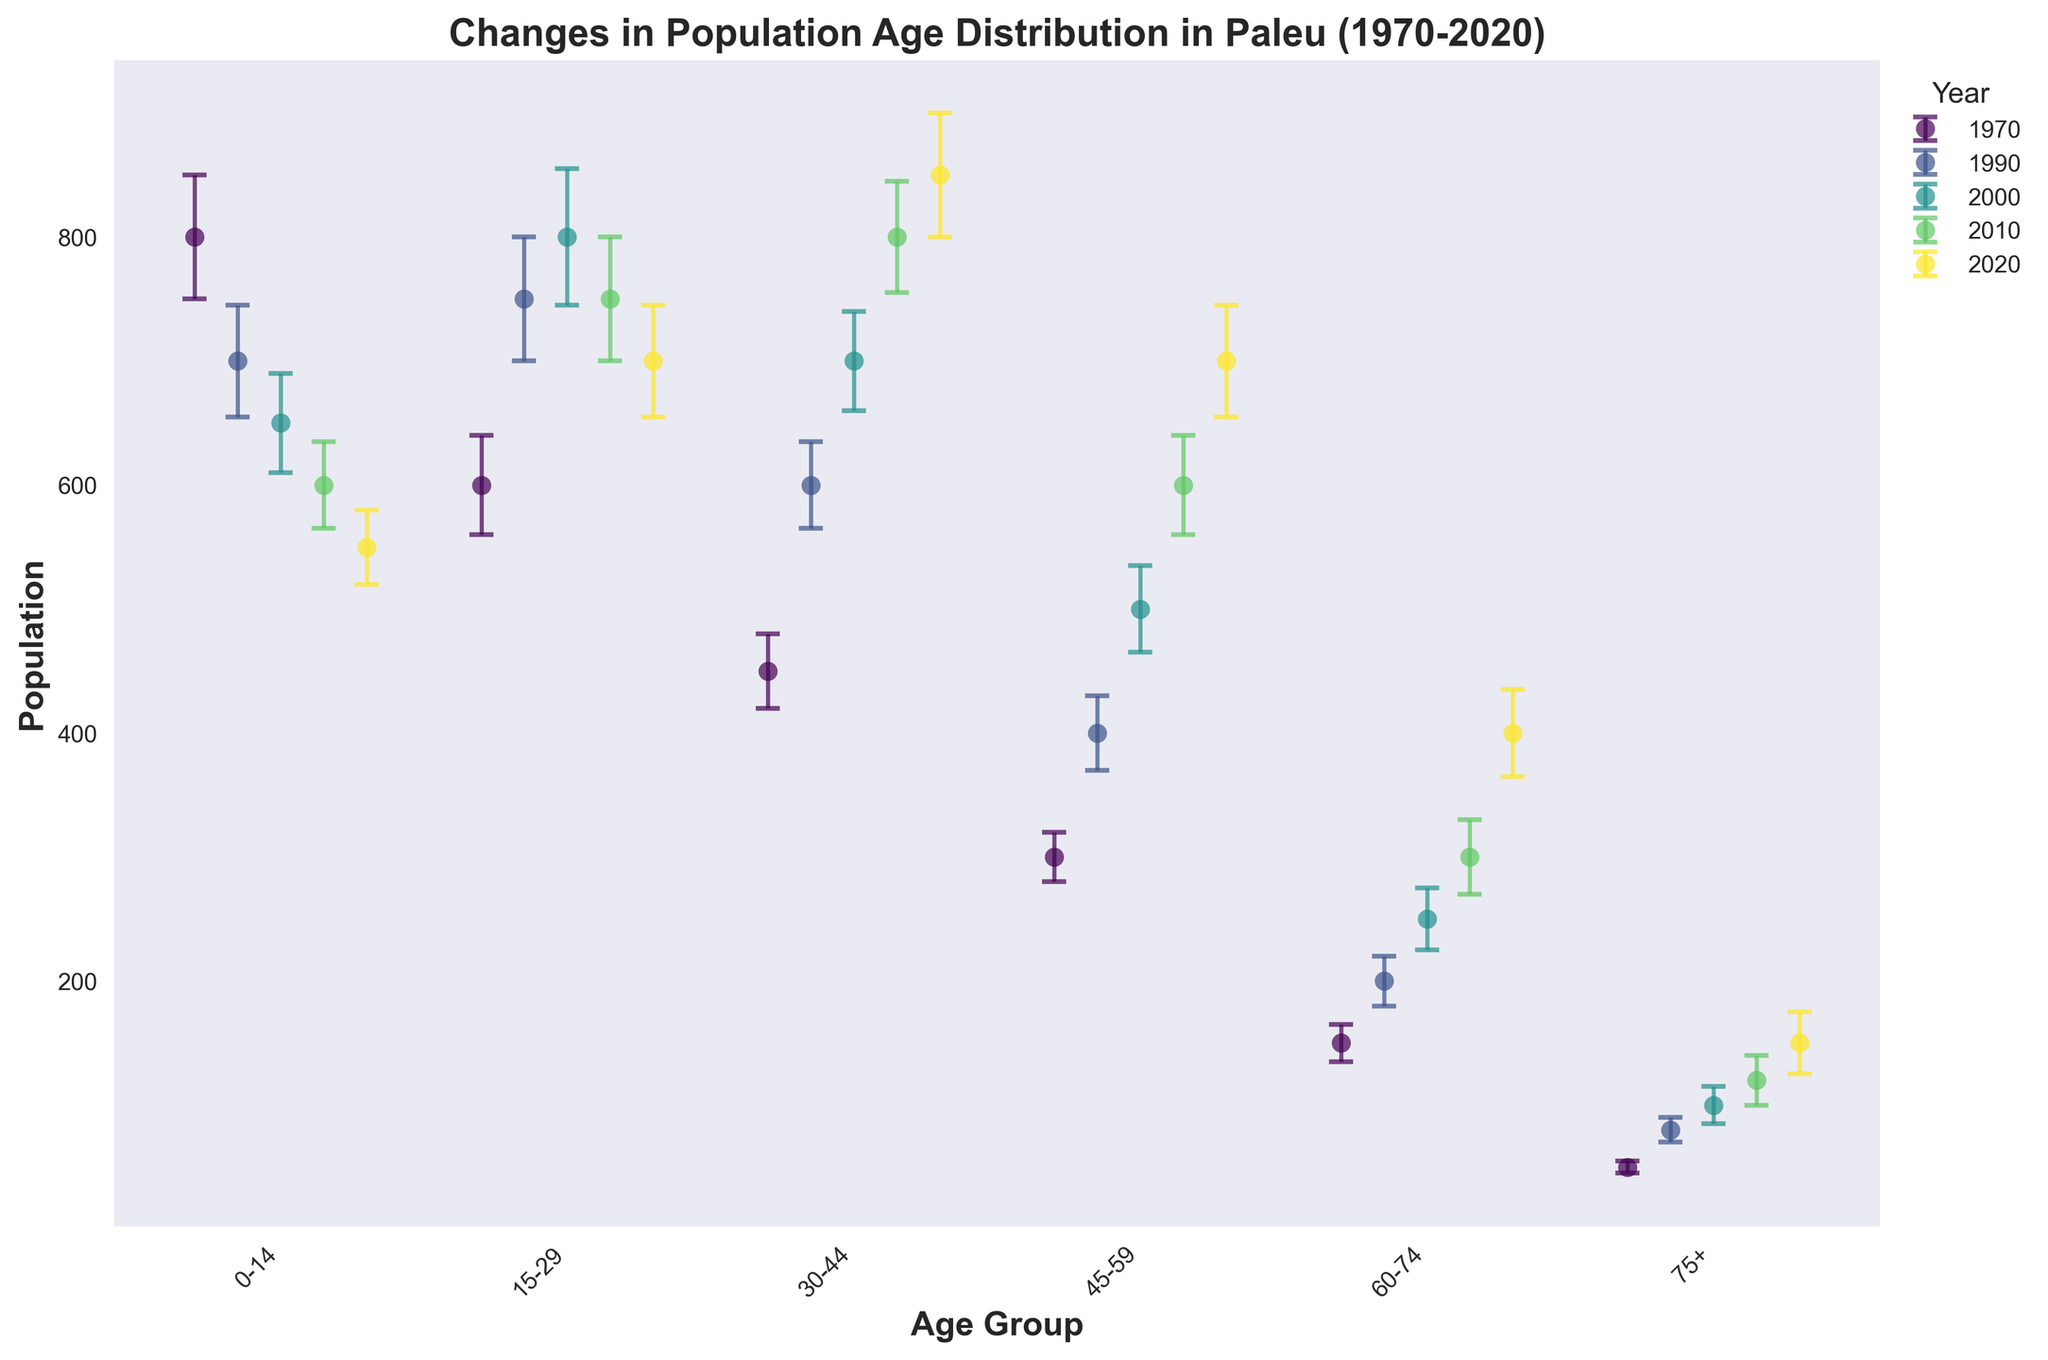What's the title of the figure? The title of the figure is typically displayed at the top of the chart. In this case, it should be obvious to spot when looking at the overall plot.
Answer: Changes in Population Age Distribution in Paleu (1970-2020) Which age group had the highest population in 2020? To determine the age group with the highest population in 2020, locate the 2020 data points and identify which age group has the highest value.
Answer: 30-44 How did the population of the age group 0-14 change from 1970 to 2020? Identify the population values for the age group 0-14 in both 1970 and 2020. Compare the two values to see the change.
Answer: Decreased What is the average population of the 60-74 age group across all years? Calculate the population for the 60-74 age group in each year (1970, 1990, 2000, 2010, 2020). Add these values and divide by the number of years. (150 + 200 + 250 + 300 + 400) / 5 = 260
Answer: 260 In which year did the age group 75+ have the lowest population? Check the population values for the age group 75+ across all years and identify the year with the lowest value.
Answer: 1970 For the year 2000, how does the population of the 45-59 age group compare to the 15-29 age group? Find the population values for the 45-59 and 15-29 age groups in 2000. Compare these values to see which is higher.
Answer: 15-29 is higher Which age group saw the most significant increase in population from 2010 to 2020? Check the population values for each age group in 2010 and 2020. Calculate the difference for each age group and determine the largest increase.
Answer: 60-74 What is the total population across all age groups in the year 1970? Sum the population values for all age groups in the year 1970: 800 + 600 + 450 + 300 +150 + 50 = 2350
Answer: 2350 Did any age group have a population decrease from 2000 to 2010? Check the population values for each age group in 2000 and 2010. Identify any age group with a lower population in 2010 compared to 2000. The age groups 0-14 and 45-59 had decreases.
Answer: Yes, 0-14 and 45-59 Which year showed a higher population in the 30-44 age group, 1990 or 2020? Compare the population values for the 30-44 age group in 1990 and 2020.
Answer: 2020 